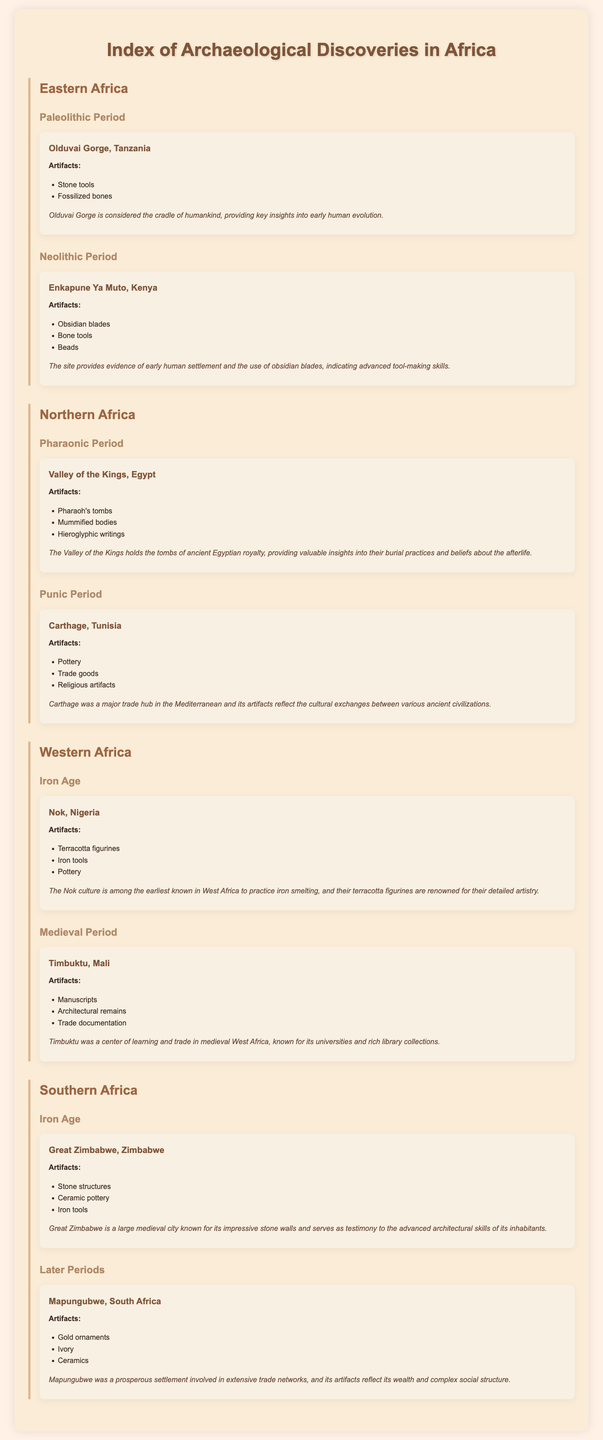What are the artifacts found in Olduvai Gorge? The document lists the artifacts excavated from Olduvai Gorge, which include stone tools and fossilized bones.
Answer: Stone tools, fossilized bones What period does Great Zimbabwe belong to? According to the document, Great Zimbabwe is classified under the Iron Age.
Answer: Iron Age What were the major artifacts excavated from Timbuktu? The necessary information can be retrieved from the document, which mentions manuscripts, architectural remains, and trade documentation.
Answer: Manuscripts, architectural remains, trade documentation What cultural significance is attributed to the Valley of the Kings? The document explains that the Valley of the Kings provides valuable insights into the burial practices and beliefs about the afterlife of ancient Egyptian royalty.
Answer: Burial practices and beliefs about the afterlife What type of artifacts were primarily found at Nok, Nigeria? The artifacts listed from Nok include terracotta figurines, iron tools, and pottery, which highlight the significance of this site's contributions to Iron Age culture.
Answer: Terracotta figurines, iron tools, pottery How is Carthage described in the document? The document describes Carthage as a major trade hub in the Mediterranean, reflected through the artifacts such as pottery and trade goods excavated from the site.
Answer: Major trade hub What does the excavation at Enkapune Ya Muto indicate about early humans? The document indicates that the site provides evidence of early human settlement and advanced tool-making skills through its obsidian blades.
Answer: Evidence of early human settlement and advanced tool-making skills Which ancient period does Mapungubwe belong to? Based on the document, Mapungubwe falls under the later periods in Southern Africa's archaeological history.
Answer: Later Periods 